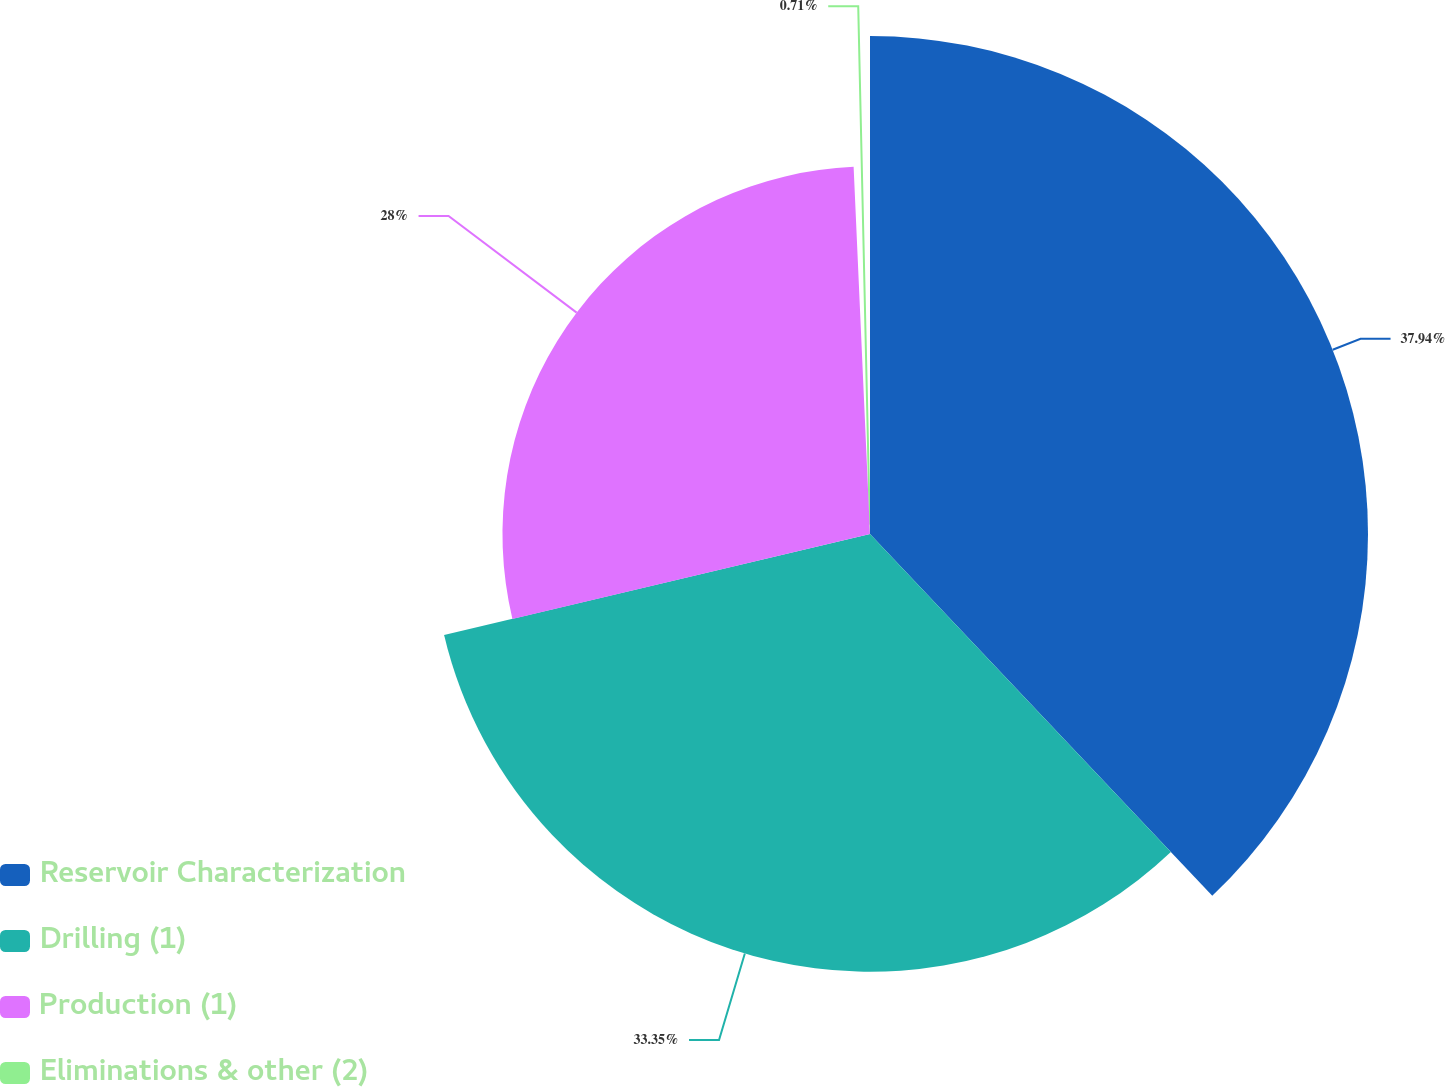Convert chart. <chart><loc_0><loc_0><loc_500><loc_500><pie_chart><fcel>Reservoir Characterization<fcel>Drilling (1)<fcel>Production (1)<fcel>Eliminations & other (2)<nl><fcel>37.94%<fcel>33.35%<fcel>28.0%<fcel>0.71%<nl></chart> 